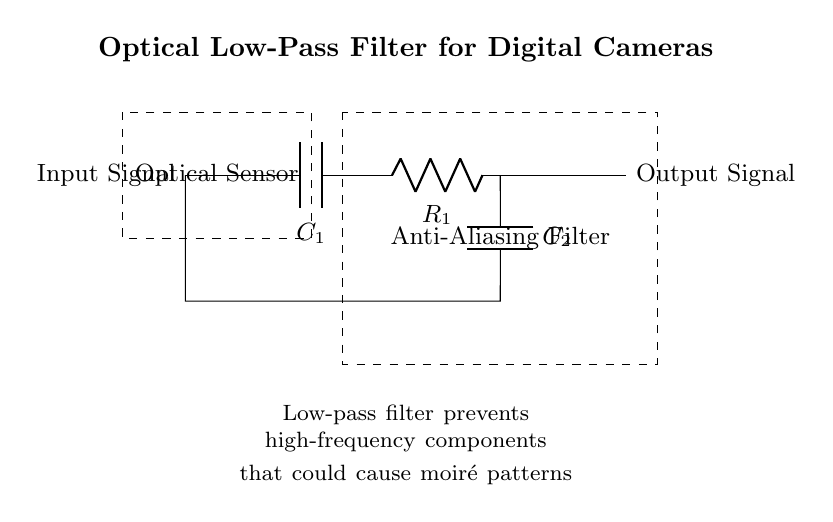What is the first component in the circuit? The first component is a capacitor labeled as C1, indicating it is the initial element in the signal path.
Answer: C1 What is the function of the anti-aliasing filter in this circuit? The anti-aliasing filter, represented within the dashed rectangle, serves to eliminate high-frequency components to avoid the occurrence of moiré patterns.
Answer: To eliminate high-frequency components How many capacitors are present in the circuit? There are two capacitors, C1 and C2, which are clearly labeled within the circuit diagram.
Answer: 2 What does the dashed rectangle represent? The dashed rectangle encompasses the optical sensor and the anti-aliasing filter, indicating that they are distinct functional blocks in the circuit.
Answer: An optical sensor and anti-aliasing filter What is the output signal connected to in this circuit? The output signal is connected to the point after the resistor R1, which indicates that the filtered signal will pass through it for further use.
Answer: After R1 What is the purpose of the low-pass filter in this circuit? The low-pass filter is designed to allow low-frequency signals to pass while attenuating higher frequencies that may lead to undesirable artifacts like moiré patterns in images.
Answer: To prevent moiré patterns What type of filter is this circuit an example of? This circuit is an example of an optical low-pass filter, specifically designed for removing high-frequency components in camera systems.
Answer: Optical low-pass filter 